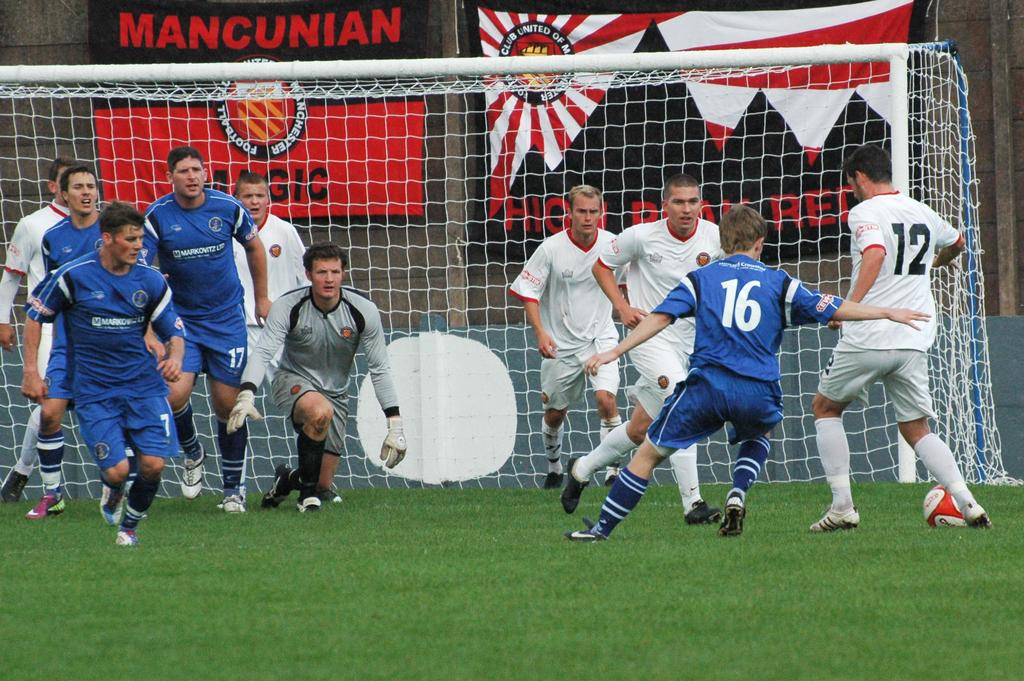Who is present in the image? There are men in the image. What is the surface the men are standing on? The men are on the grass. What type of vegetation can be seen in the image? There is grass visible in the image. What can be seen in the background of the image? There is a net and flags in the background of the image. Where is the chair located in the image? There is no chair present in the image. What type of wing can be seen flying in the image? There is no wing or any flying object present in the image. 